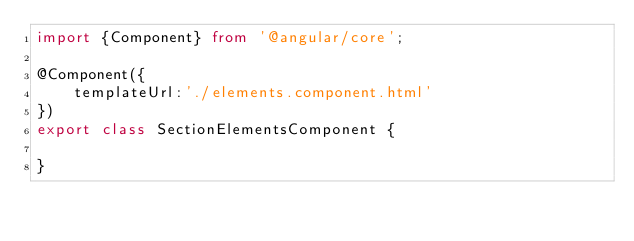Convert code to text. <code><loc_0><loc_0><loc_500><loc_500><_TypeScript_>import {Component} from '@angular/core';

@Component({
    templateUrl:'./elements.component.html'
})
export class SectionElementsComponent {

}</code> 